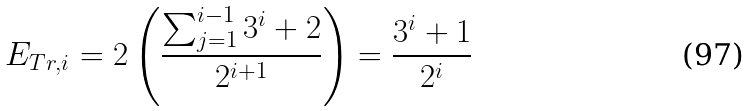<formula> <loc_0><loc_0><loc_500><loc_500>E _ { T r , i } = 2 \left ( \frac { \sum _ { j = 1 } ^ { i - 1 } 3 ^ { i } + 2 } { 2 ^ { i + 1 } } \right ) = \frac { 3 ^ { i } + 1 } { 2 ^ { i } }</formula> 